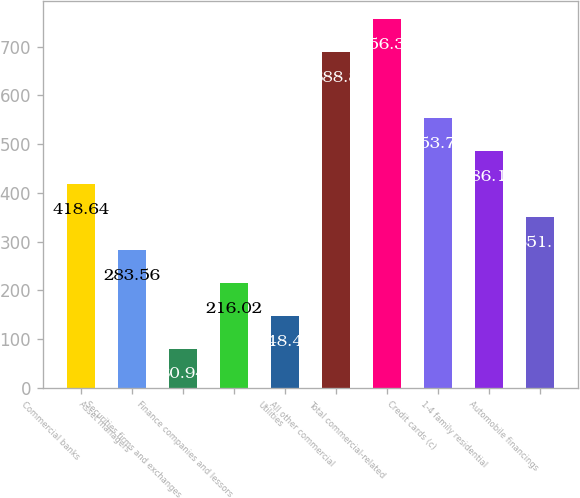Convert chart to OTSL. <chart><loc_0><loc_0><loc_500><loc_500><bar_chart><fcel>Commercial banks<fcel>Asset managers<fcel>Securities firms and exchanges<fcel>Finance companies and lessors<fcel>Utilities<fcel>All other commercial<fcel>Total commercial-related<fcel>Credit cards (c)<fcel>1-4 family residential<fcel>Automobile financings<nl><fcel>418.64<fcel>283.56<fcel>80.94<fcel>216.02<fcel>148.48<fcel>688.8<fcel>756.34<fcel>553.72<fcel>486.18<fcel>351.1<nl></chart> 